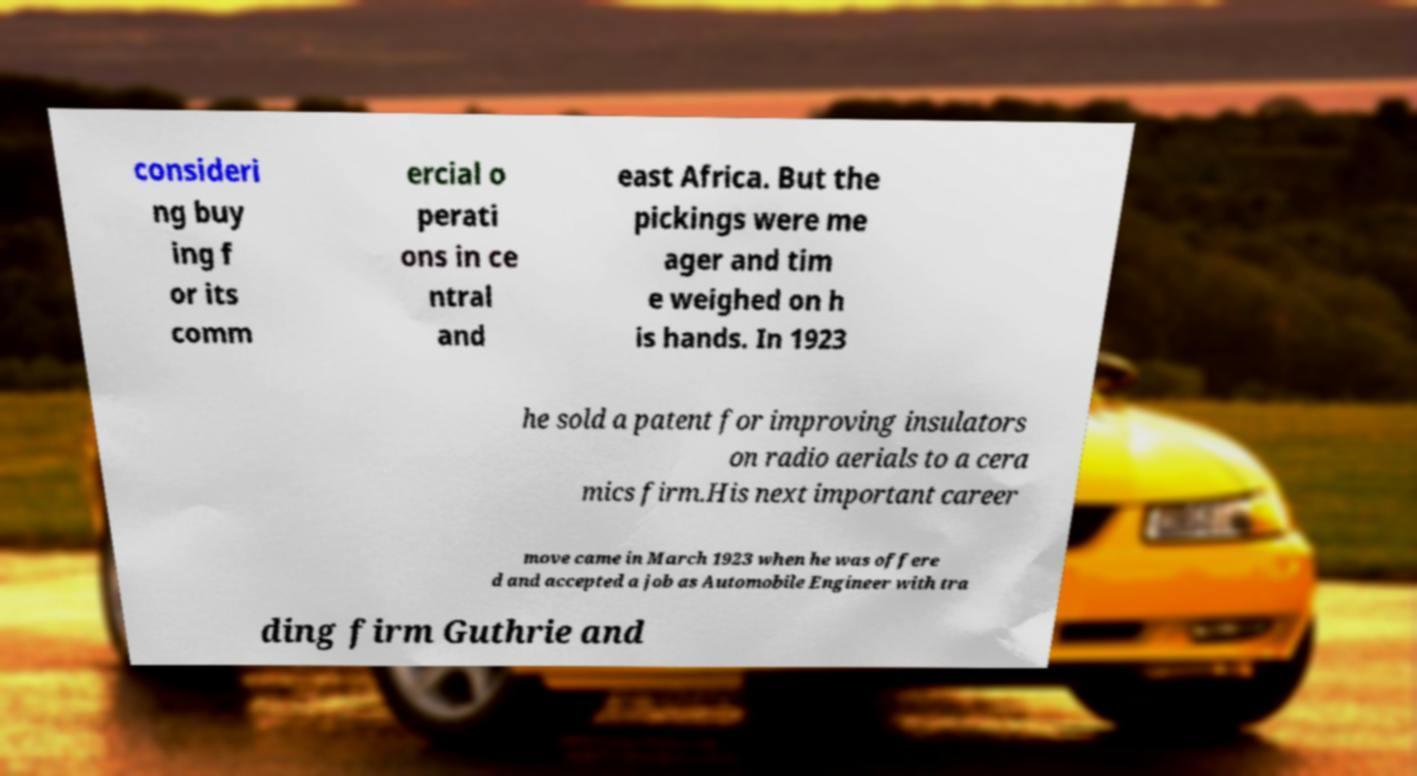Can you read and provide the text displayed in the image?This photo seems to have some interesting text. Can you extract and type it out for me? consideri ng buy ing f or its comm ercial o perati ons in ce ntral and east Africa. But the pickings were me ager and tim e weighed on h is hands. In 1923 he sold a patent for improving insulators on radio aerials to a cera mics firm.His next important career move came in March 1923 when he was offere d and accepted a job as Automobile Engineer with tra ding firm Guthrie and 